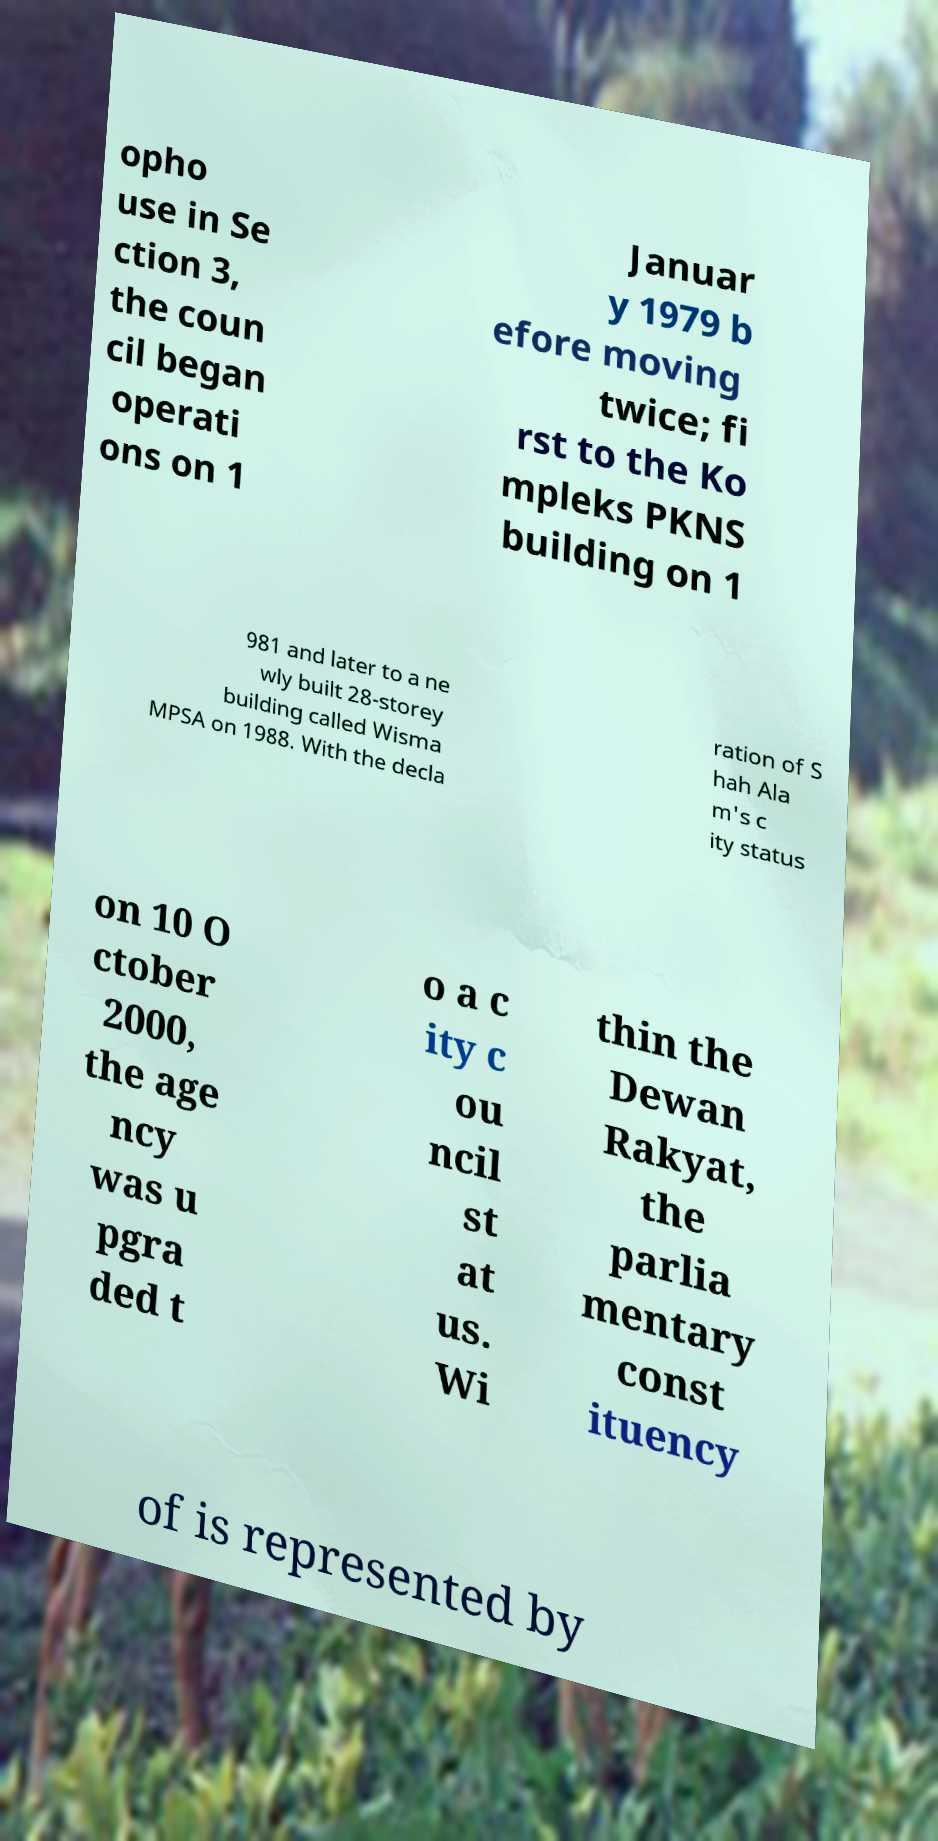For documentation purposes, I need the text within this image transcribed. Could you provide that? opho use in Se ction 3, the coun cil began operati ons on 1 Januar y 1979 b efore moving twice; fi rst to the Ko mpleks PKNS building on 1 981 and later to a ne wly built 28-storey building called Wisma MPSA on 1988. With the decla ration of S hah Ala m's c ity status on 10 O ctober 2000, the age ncy was u pgra ded t o a c ity c ou ncil st at us. Wi thin the Dewan Rakyat, the parlia mentary const ituency of is represented by 